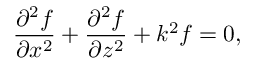Convert formula to latex. <formula><loc_0><loc_0><loc_500><loc_500>\frac { \partial ^ { 2 } f } { \partial { x ^ { 2 } } } + \frac { \partial ^ { 2 } f } { \partial { z ^ { 2 } } } + k ^ { 2 } f = 0 ,</formula> 